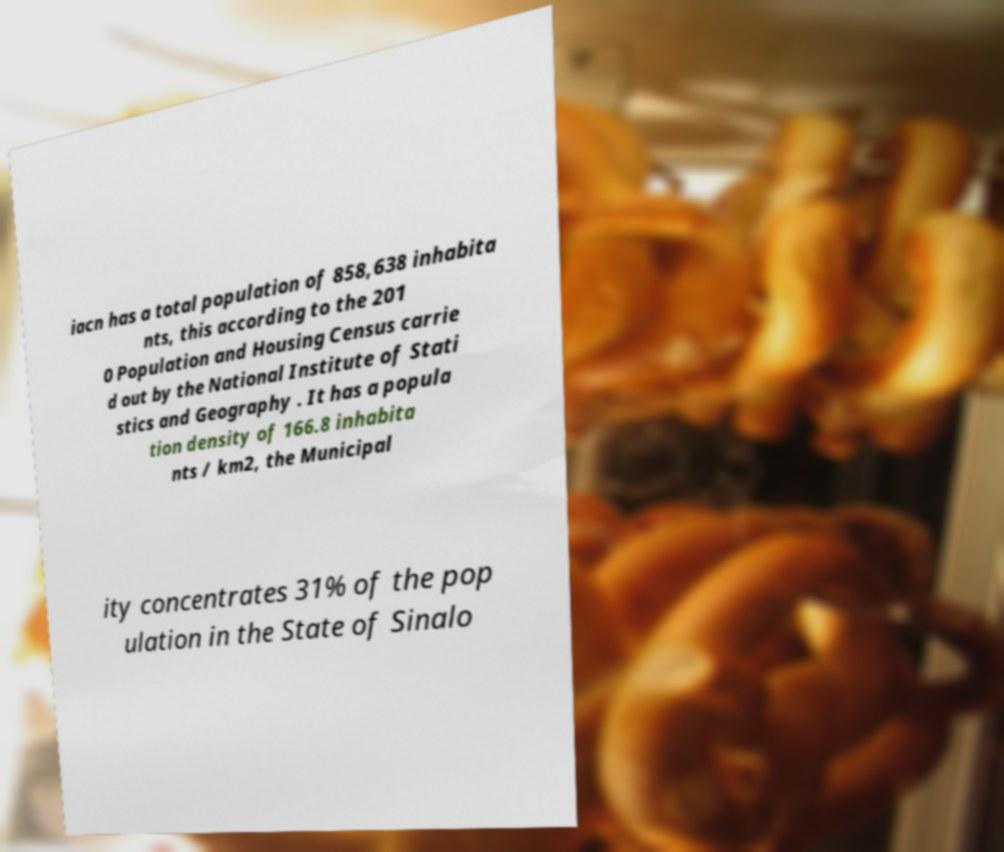Please identify and transcribe the text found in this image. iacn has a total population of 858,638 inhabita nts, this according to the 201 0 Population and Housing Census carrie d out by the National Institute of Stati stics and Geography . It has a popula tion density of 166.8 inhabita nts / km2, the Municipal ity concentrates 31% of the pop ulation in the State of Sinalo 